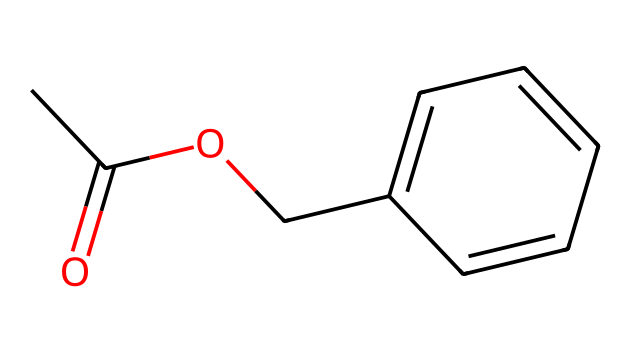What is the name of this ester? The SMILES representation indicates that the molecule contains a benzyl group (Cc1ccccc1) connected to an acetate group (CC(=O)O). This structure matches the compound known as benzyl acetate.
Answer: benzyl acetate How many carbon atoms are present in benzyl acetate? By analyzing the SMILES, there are a total of 9 carbon atoms: 2 from the acetate part (CC) and 7 from the benzyl group (Cc1ccccc1).
Answer: 9 What is the functional group of this chemical? The presence of the carbonyl group (C=O) and the ether linkage (O) in the structure identifies it as an ester, specifically characterized by the -COO- group.
Answer: ester How many hydrogen atoms are in benzyl acetate? In the structure, there are 10 hydrogen atoms: 3 from the acetate group and 7 from the benzyl group, which is represented as Cc1ccccc1 (with one hydrogen replaced by the acetate).
Answer: 10 What type of reaction is involved in the formation of benzyl acetate? The formation of benzyl acetate typically occurs through a condensation reaction (specifically an esterification) between a carboxylic acid and an alcohol.
Answer: esterification What is the total number of oxygen atoms in benzyl acetate? The structure contains 2 oxygen atoms, one in the carbonyl (C=O) and one in the ether part (-O-), confirming the presence of the ester functional group.
Answer: 2 